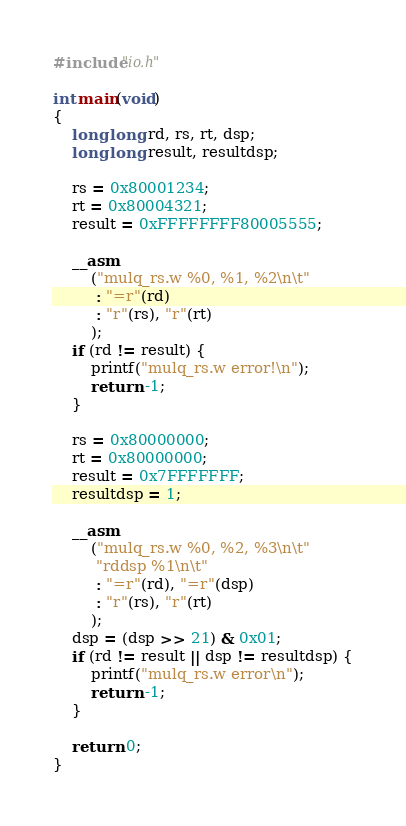Convert code to text. <code><loc_0><loc_0><loc_500><loc_500><_C_>#include"io.h"

int main(void)
{
    long long rd, rs, rt, dsp;
    long long result, resultdsp;

    rs = 0x80001234;
    rt = 0x80004321;
    result = 0xFFFFFFFF80005555;

    __asm
        ("mulq_rs.w %0, %1, %2\n\t"
         : "=r"(rd)
         : "r"(rs), "r"(rt)
        );
    if (rd != result) {
        printf("mulq_rs.w error!\n");
        return -1;
    }

    rs = 0x80000000;
    rt = 0x80000000;
    result = 0x7FFFFFFF;
    resultdsp = 1;

    __asm
        ("mulq_rs.w %0, %2, %3\n\t"
         "rddsp %1\n\t"
         : "=r"(rd), "=r"(dsp)
         : "r"(rs), "r"(rt)
        );
    dsp = (dsp >> 21) & 0x01;
    if (rd != result || dsp != resultdsp) {
        printf("mulq_rs.w error\n");
        return -1;
    }

    return 0;
}
</code> 